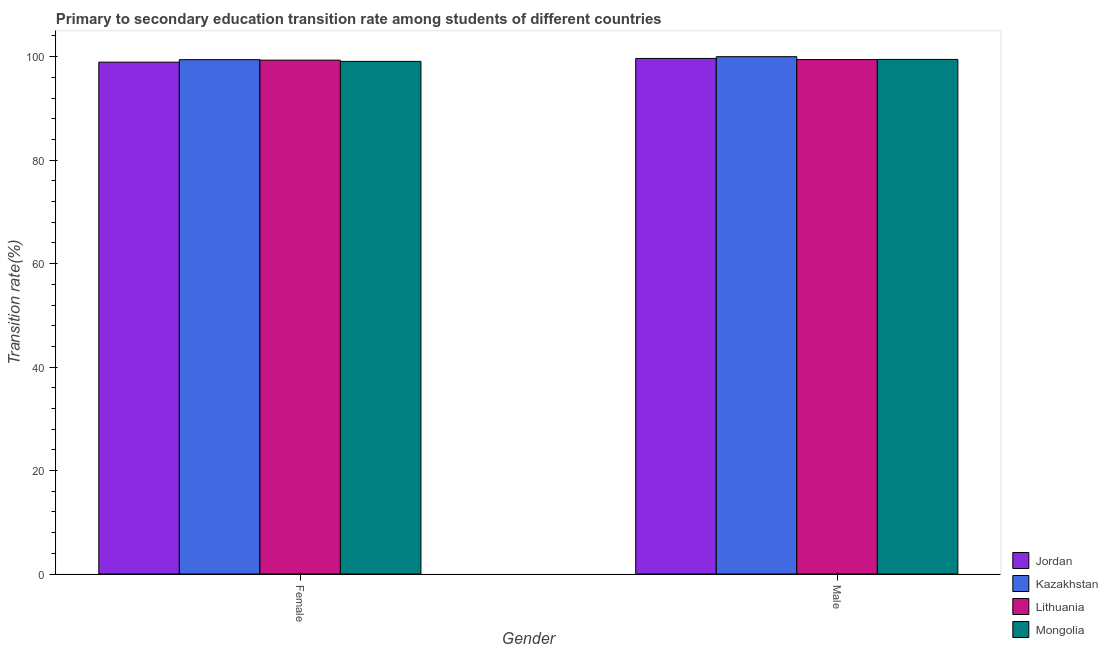Are the number of bars per tick equal to the number of legend labels?
Your response must be concise. Yes. Are the number of bars on each tick of the X-axis equal?
Keep it short and to the point. Yes. How many bars are there on the 1st tick from the left?
Make the answer very short. 4. How many bars are there on the 1st tick from the right?
Offer a very short reply. 4. What is the transition rate among male students in Lithuania?
Ensure brevity in your answer.  99.45. Across all countries, what is the maximum transition rate among male students?
Offer a very short reply. 100. Across all countries, what is the minimum transition rate among male students?
Your response must be concise. 99.45. In which country was the transition rate among male students maximum?
Your answer should be compact. Kazakhstan. In which country was the transition rate among male students minimum?
Offer a very short reply. Lithuania. What is the total transition rate among female students in the graph?
Keep it short and to the point. 396.79. What is the difference between the transition rate among female students in Lithuania and that in Mongolia?
Offer a terse response. 0.24. What is the difference between the transition rate among female students in Mongolia and the transition rate among male students in Jordan?
Your answer should be very brief. -0.57. What is the average transition rate among female students per country?
Ensure brevity in your answer.  99.2. What is the difference between the transition rate among male students and transition rate among female students in Mongolia?
Your response must be concise. 0.38. In how many countries, is the transition rate among male students greater than 20 %?
Offer a very short reply. 4. What is the ratio of the transition rate among male students in Lithuania to that in Mongolia?
Your answer should be compact. 1. Is the transition rate among female students in Lithuania less than that in Jordan?
Ensure brevity in your answer.  No. What does the 1st bar from the left in Male represents?
Keep it short and to the point. Jordan. What does the 1st bar from the right in Female represents?
Your answer should be very brief. Mongolia. Are all the bars in the graph horizontal?
Your response must be concise. No. What is the difference between two consecutive major ticks on the Y-axis?
Offer a very short reply. 20. Are the values on the major ticks of Y-axis written in scientific E-notation?
Offer a terse response. No. Does the graph contain any zero values?
Give a very brief answer. No. Where does the legend appear in the graph?
Ensure brevity in your answer.  Bottom right. How many legend labels are there?
Give a very brief answer. 4. How are the legend labels stacked?
Keep it short and to the point. Vertical. What is the title of the graph?
Provide a succinct answer. Primary to secondary education transition rate among students of different countries. Does "Mexico" appear as one of the legend labels in the graph?
Your response must be concise. No. What is the label or title of the Y-axis?
Keep it short and to the point. Transition rate(%). What is the Transition rate(%) of Jordan in Female?
Keep it short and to the point. 98.95. What is the Transition rate(%) in Kazakhstan in Female?
Your answer should be compact. 99.42. What is the Transition rate(%) in Lithuania in Female?
Your response must be concise. 99.33. What is the Transition rate(%) of Mongolia in Female?
Keep it short and to the point. 99.09. What is the Transition rate(%) in Jordan in Male?
Provide a short and direct response. 99.66. What is the Transition rate(%) of Lithuania in Male?
Provide a short and direct response. 99.45. What is the Transition rate(%) in Mongolia in Male?
Make the answer very short. 99.47. Across all Gender, what is the maximum Transition rate(%) of Jordan?
Offer a very short reply. 99.66. Across all Gender, what is the maximum Transition rate(%) in Lithuania?
Give a very brief answer. 99.45. Across all Gender, what is the maximum Transition rate(%) of Mongolia?
Provide a succinct answer. 99.47. Across all Gender, what is the minimum Transition rate(%) in Jordan?
Provide a succinct answer. 98.95. Across all Gender, what is the minimum Transition rate(%) of Kazakhstan?
Offer a terse response. 99.42. Across all Gender, what is the minimum Transition rate(%) of Lithuania?
Offer a very short reply. 99.33. Across all Gender, what is the minimum Transition rate(%) of Mongolia?
Offer a terse response. 99.09. What is the total Transition rate(%) of Jordan in the graph?
Your answer should be very brief. 198.61. What is the total Transition rate(%) in Kazakhstan in the graph?
Your response must be concise. 199.42. What is the total Transition rate(%) in Lithuania in the graph?
Your answer should be very brief. 198.78. What is the total Transition rate(%) in Mongolia in the graph?
Keep it short and to the point. 198.56. What is the difference between the Transition rate(%) of Jordan in Female and that in Male?
Make the answer very short. -0.71. What is the difference between the Transition rate(%) in Kazakhstan in Female and that in Male?
Your response must be concise. -0.58. What is the difference between the Transition rate(%) of Lithuania in Female and that in Male?
Keep it short and to the point. -0.12. What is the difference between the Transition rate(%) in Mongolia in Female and that in Male?
Your response must be concise. -0.38. What is the difference between the Transition rate(%) of Jordan in Female and the Transition rate(%) of Kazakhstan in Male?
Ensure brevity in your answer.  -1.05. What is the difference between the Transition rate(%) in Jordan in Female and the Transition rate(%) in Lithuania in Male?
Ensure brevity in your answer.  -0.5. What is the difference between the Transition rate(%) in Jordan in Female and the Transition rate(%) in Mongolia in Male?
Keep it short and to the point. -0.52. What is the difference between the Transition rate(%) in Kazakhstan in Female and the Transition rate(%) in Lithuania in Male?
Offer a very short reply. -0.03. What is the difference between the Transition rate(%) of Kazakhstan in Female and the Transition rate(%) of Mongolia in Male?
Provide a short and direct response. -0.05. What is the difference between the Transition rate(%) of Lithuania in Female and the Transition rate(%) of Mongolia in Male?
Ensure brevity in your answer.  -0.14. What is the average Transition rate(%) in Jordan per Gender?
Keep it short and to the point. 99.3. What is the average Transition rate(%) in Kazakhstan per Gender?
Keep it short and to the point. 99.71. What is the average Transition rate(%) of Lithuania per Gender?
Ensure brevity in your answer.  99.39. What is the average Transition rate(%) in Mongolia per Gender?
Give a very brief answer. 99.28. What is the difference between the Transition rate(%) of Jordan and Transition rate(%) of Kazakhstan in Female?
Provide a succinct answer. -0.48. What is the difference between the Transition rate(%) of Jordan and Transition rate(%) of Lithuania in Female?
Offer a terse response. -0.39. What is the difference between the Transition rate(%) of Jordan and Transition rate(%) of Mongolia in Female?
Your answer should be very brief. -0.15. What is the difference between the Transition rate(%) in Kazakhstan and Transition rate(%) in Lithuania in Female?
Your answer should be very brief. 0.09. What is the difference between the Transition rate(%) of Kazakhstan and Transition rate(%) of Mongolia in Female?
Your answer should be very brief. 0.33. What is the difference between the Transition rate(%) of Lithuania and Transition rate(%) of Mongolia in Female?
Make the answer very short. 0.24. What is the difference between the Transition rate(%) of Jordan and Transition rate(%) of Kazakhstan in Male?
Ensure brevity in your answer.  -0.34. What is the difference between the Transition rate(%) in Jordan and Transition rate(%) in Lithuania in Male?
Your response must be concise. 0.21. What is the difference between the Transition rate(%) of Jordan and Transition rate(%) of Mongolia in Male?
Offer a terse response. 0.19. What is the difference between the Transition rate(%) in Kazakhstan and Transition rate(%) in Lithuania in Male?
Keep it short and to the point. 0.55. What is the difference between the Transition rate(%) in Kazakhstan and Transition rate(%) in Mongolia in Male?
Make the answer very short. 0.53. What is the difference between the Transition rate(%) of Lithuania and Transition rate(%) of Mongolia in Male?
Your answer should be compact. -0.02. What is the ratio of the Transition rate(%) in Kazakhstan in Female to that in Male?
Provide a short and direct response. 0.99. What is the ratio of the Transition rate(%) in Lithuania in Female to that in Male?
Your response must be concise. 1. What is the difference between the highest and the second highest Transition rate(%) of Jordan?
Offer a terse response. 0.71. What is the difference between the highest and the second highest Transition rate(%) of Kazakhstan?
Offer a terse response. 0.58. What is the difference between the highest and the second highest Transition rate(%) in Lithuania?
Your answer should be compact. 0.12. What is the difference between the highest and the second highest Transition rate(%) of Mongolia?
Offer a terse response. 0.38. What is the difference between the highest and the lowest Transition rate(%) of Jordan?
Provide a short and direct response. 0.71. What is the difference between the highest and the lowest Transition rate(%) of Kazakhstan?
Give a very brief answer. 0.58. What is the difference between the highest and the lowest Transition rate(%) in Lithuania?
Provide a succinct answer. 0.12. What is the difference between the highest and the lowest Transition rate(%) of Mongolia?
Give a very brief answer. 0.38. 